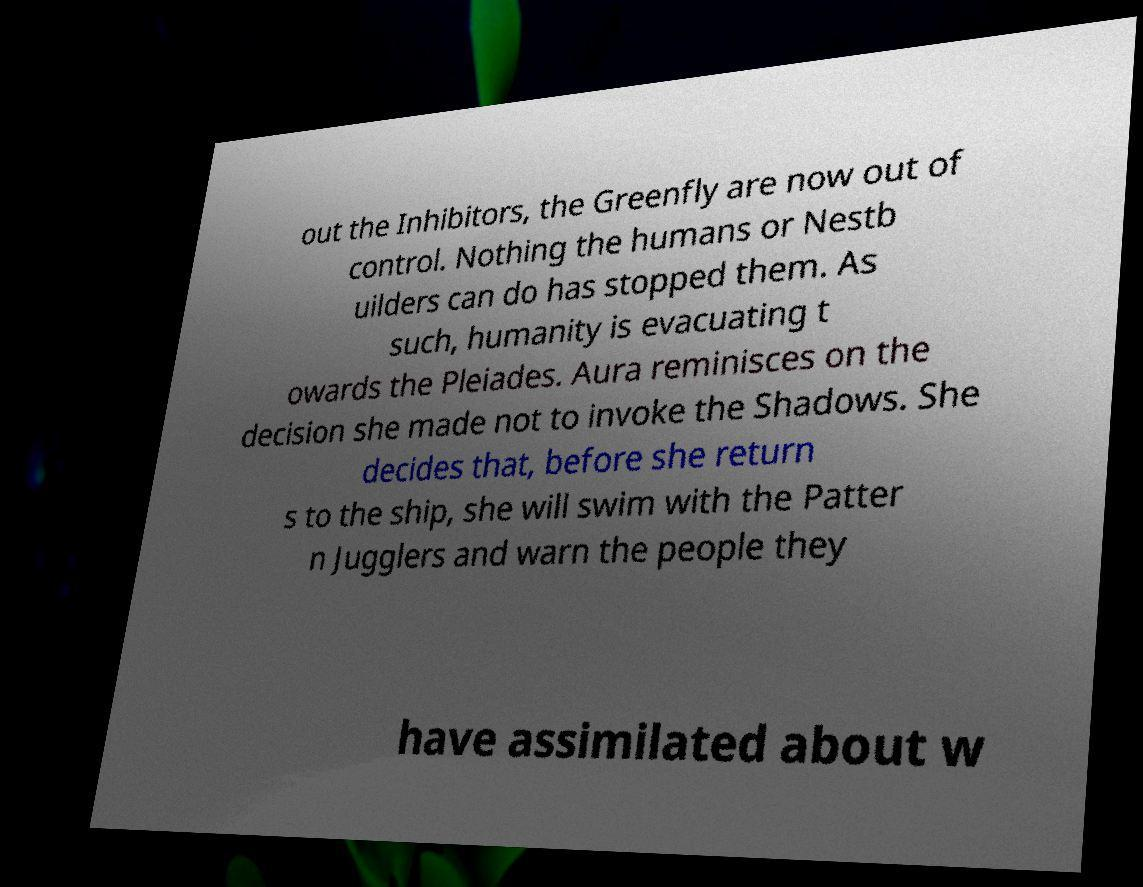There's text embedded in this image that I need extracted. Can you transcribe it verbatim? out the Inhibitors, the Greenfly are now out of control. Nothing the humans or Nestb uilders can do has stopped them. As such, humanity is evacuating t owards the Pleiades. Aura reminisces on the decision she made not to invoke the Shadows. She decides that, before she return s to the ship, she will swim with the Patter n Jugglers and warn the people they have assimilated about w 